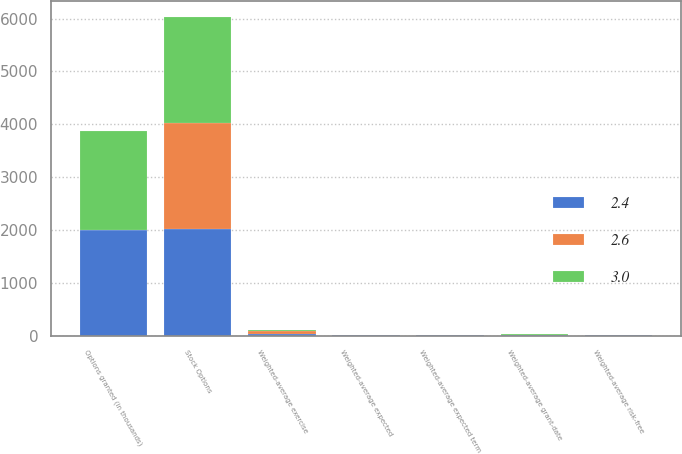<chart> <loc_0><loc_0><loc_500><loc_500><stacked_bar_chart><ecel><fcel>Stock Options<fcel>Options granted (in thousands)<fcel>Weighted-average exercise<fcel>Weighted-average grant-date<fcel>Weighted-average expected<fcel>Weighted-average expected term<fcel>Weighted-average risk-free<nl><fcel>2.6<fcel>2012<fcel>8.62<fcel>39.58<fcel>7.37<fcel>3<fcel>5.3<fcel>1.1<nl><fcel>2.4<fcel>2011<fcel>1990<fcel>37.59<fcel>8.62<fcel>2.4<fcel>5.3<fcel>2.1<nl><fcel>3<fcel>2010<fcel>1866<fcel>31.49<fcel>7.77<fcel>2.6<fcel>5.3<fcel>2.5<nl></chart> 